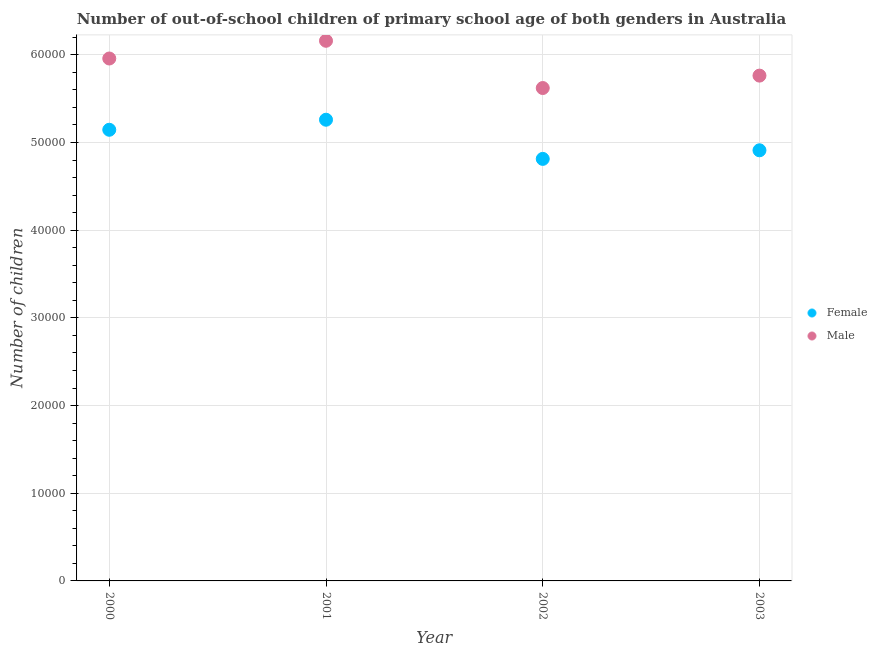Is the number of dotlines equal to the number of legend labels?
Give a very brief answer. Yes. What is the number of male out-of-school students in 2002?
Your answer should be compact. 5.62e+04. Across all years, what is the maximum number of female out-of-school students?
Provide a short and direct response. 5.26e+04. Across all years, what is the minimum number of male out-of-school students?
Offer a terse response. 5.62e+04. What is the total number of male out-of-school students in the graph?
Your answer should be very brief. 2.35e+05. What is the difference between the number of female out-of-school students in 2000 and that in 2002?
Provide a succinct answer. 3321. What is the difference between the number of male out-of-school students in 2001 and the number of female out-of-school students in 2000?
Provide a short and direct response. 1.01e+04. What is the average number of female out-of-school students per year?
Your response must be concise. 5.03e+04. In the year 2002, what is the difference between the number of male out-of-school students and number of female out-of-school students?
Your answer should be compact. 8081. In how many years, is the number of female out-of-school students greater than 34000?
Your answer should be very brief. 4. What is the ratio of the number of male out-of-school students in 2000 to that in 2002?
Your answer should be very brief. 1.06. Is the difference between the number of male out-of-school students in 2001 and 2002 greater than the difference between the number of female out-of-school students in 2001 and 2002?
Provide a short and direct response. Yes. What is the difference between the highest and the second highest number of female out-of-school students?
Your answer should be compact. 1145. What is the difference between the highest and the lowest number of male out-of-school students?
Keep it short and to the point. 5388. Is the number of male out-of-school students strictly less than the number of female out-of-school students over the years?
Offer a terse response. No. How many dotlines are there?
Make the answer very short. 2. How many years are there in the graph?
Provide a short and direct response. 4. Are the values on the major ticks of Y-axis written in scientific E-notation?
Offer a terse response. No. Does the graph contain any zero values?
Make the answer very short. No. Where does the legend appear in the graph?
Give a very brief answer. Center right. How many legend labels are there?
Give a very brief answer. 2. How are the legend labels stacked?
Offer a terse response. Vertical. What is the title of the graph?
Offer a very short reply. Number of out-of-school children of primary school age of both genders in Australia. What is the label or title of the Y-axis?
Offer a terse response. Number of children. What is the Number of children in Female in 2000?
Your response must be concise. 5.14e+04. What is the Number of children in Male in 2000?
Your answer should be compact. 5.96e+04. What is the Number of children in Female in 2001?
Offer a very short reply. 5.26e+04. What is the Number of children of Male in 2001?
Your response must be concise. 6.16e+04. What is the Number of children in Female in 2002?
Make the answer very short. 4.81e+04. What is the Number of children in Male in 2002?
Offer a terse response. 5.62e+04. What is the Number of children in Female in 2003?
Make the answer very short. 4.91e+04. What is the Number of children in Male in 2003?
Offer a very short reply. 5.76e+04. Across all years, what is the maximum Number of children of Female?
Give a very brief answer. 5.26e+04. Across all years, what is the maximum Number of children in Male?
Your answer should be very brief. 6.16e+04. Across all years, what is the minimum Number of children in Female?
Offer a terse response. 4.81e+04. Across all years, what is the minimum Number of children in Male?
Keep it short and to the point. 5.62e+04. What is the total Number of children in Female in the graph?
Provide a short and direct response. 2.01e+05. What is the total Number of children of Male in the graph?
Keep it short and to the point. 2.35e+05. What is the difference between the Number of children in Female in 2000 and that in 2001?
Your response must be concise. -1145. What is the difference between the Number of children in Male in 2000 and that in 2001?
Your answer should be very brief. -2021. What is the difference between the Number of children in Female in 2000 and that in 2002?
Make the answer very short. 3321. What is the difference between the Number of children in Male in 2000 and that in 2002?
Make the answer very short. 3367. What is the difference between the Number of children in Female in 2000 and that in 2003?
Your response must be concise. 2341. What is the difference between the Number of children of Male in 2000 and that in 2003?
Your response must be concise. 1952. What is the difference between the Number of children of Female in 2001 and that in 2002?
Make the answer very short. 4466. What is the difference between the Number of children of Male in 2001 and that in 2002?
Your answer should be very brief. 5388. What is the difference between the Number of children of Female in 2001 and that in 2003?
Give a very brief answer. 3486. What is the difference between the Number of children of Male in 2001 and that in 2003?
Give a very brief answer. 3973. What is the difference between the Number of children of Female in 2002 and that in 2003?
Provide a short and direct response. -980. What is the difference between the Number of children in Male in 2002 and that in 2003?
Offer a very short reply. -1415. What is the difference between the Number of children in Female in 2000 and the Number of children in Male in 2001?
Your response must be concise. -1.01e+04. What is the difference between the Number of children of Female in 2000 and the Number of children of Male in 2002?
Give a very brief answer. -4760. What is the difference between the Number of children of Female in 2000 and the Number of children of Male in 2003?
Keep it short and to the point. -6175. What is the difference between the Number of children of Female in 2001 and the Number of children of Male in 2002?
Your response must be concise. -3615. What is the difference between the Number of children in Female in 2001 and the Number of children in Male in 2003?
Make the answer very short. -5030. What is the difference between the Number of children in Female in 2002 and the Number of children in Male in 2003?
Your response must be concise. -9496. What is the average Number of children in Female per year?
Your answer should be compact. 5.03e+04. What is the average Number of children in Male per year?
Provide a short and direct response. 5.88e+04. In the year 2000, what is the difference between the Number of children in Female and Number of children in Male?
Offer a terse response. -8127. In the year 2001, what is the difference between the Number of children in Female and Number of children in Male?
Your response must be concise. -9003. In the year 2002, what is the difference between the Number of children of Female and Number of children of Male?
Your response must be concise. -8081. In the year 2003, what is the difference between the Number of children of Female and Number of children of Male?
Keep it short and to the point. -8516. What is the ratio of the Number of children of Female in 2000 to that in 2001?
Provide a short and direct response. 0.98. What is the ratio of the Number of children of Male in 2000 to that in 2001?
Your answer should be very brief. 0.97. What is the ratio of the Number of children of Female in 2000 to that in 2002?
Offer a very short reply. 1.07. What is the ratio of the Number of children in Male in 2000 to that in 2002?
Provide a short and direct response. 1.06. What is the ratio of the Number of children of Female in 2000 to that in 2003?
Make the answer very short. 1.05. What is the ratio of the Number of children of Male in 2000 to that in 2003?
Provide a short and direct response. 1.03. What is the ratio of the Number of children of Female in 2001 to that in 2002?
Your answer should be very brief. 1.09. What is the ratio of the Number of children of Male in 2001 to that in 2002?
Your response must be concise. 1.1. What is the ratio of the Number of children of Female in 2001 to that in 2003?
Make the answer very short. 1.07. What is the ratio of the Number of children of Male in 2001 to that in 2003?
Ensure brevity in your answer.  1.07. What is the ratio of the Number of children of Male in 2002 to that in 2003?
Your response must be concise. 0.98. What is the difference between the highest and the second highest Number of children of Female?
Provide a succinct answer. 1145. What is the difference between the highest and the second highest Number of children in Male?
Your answer should be very brief. 2021. What is the difference between the highest and the lowest Number of children of Female?
Keep it short and to the point. 4466. What is the difference between the highest and the lowest Number of children of Male?
Ensure brevity in your answer.  5388. 